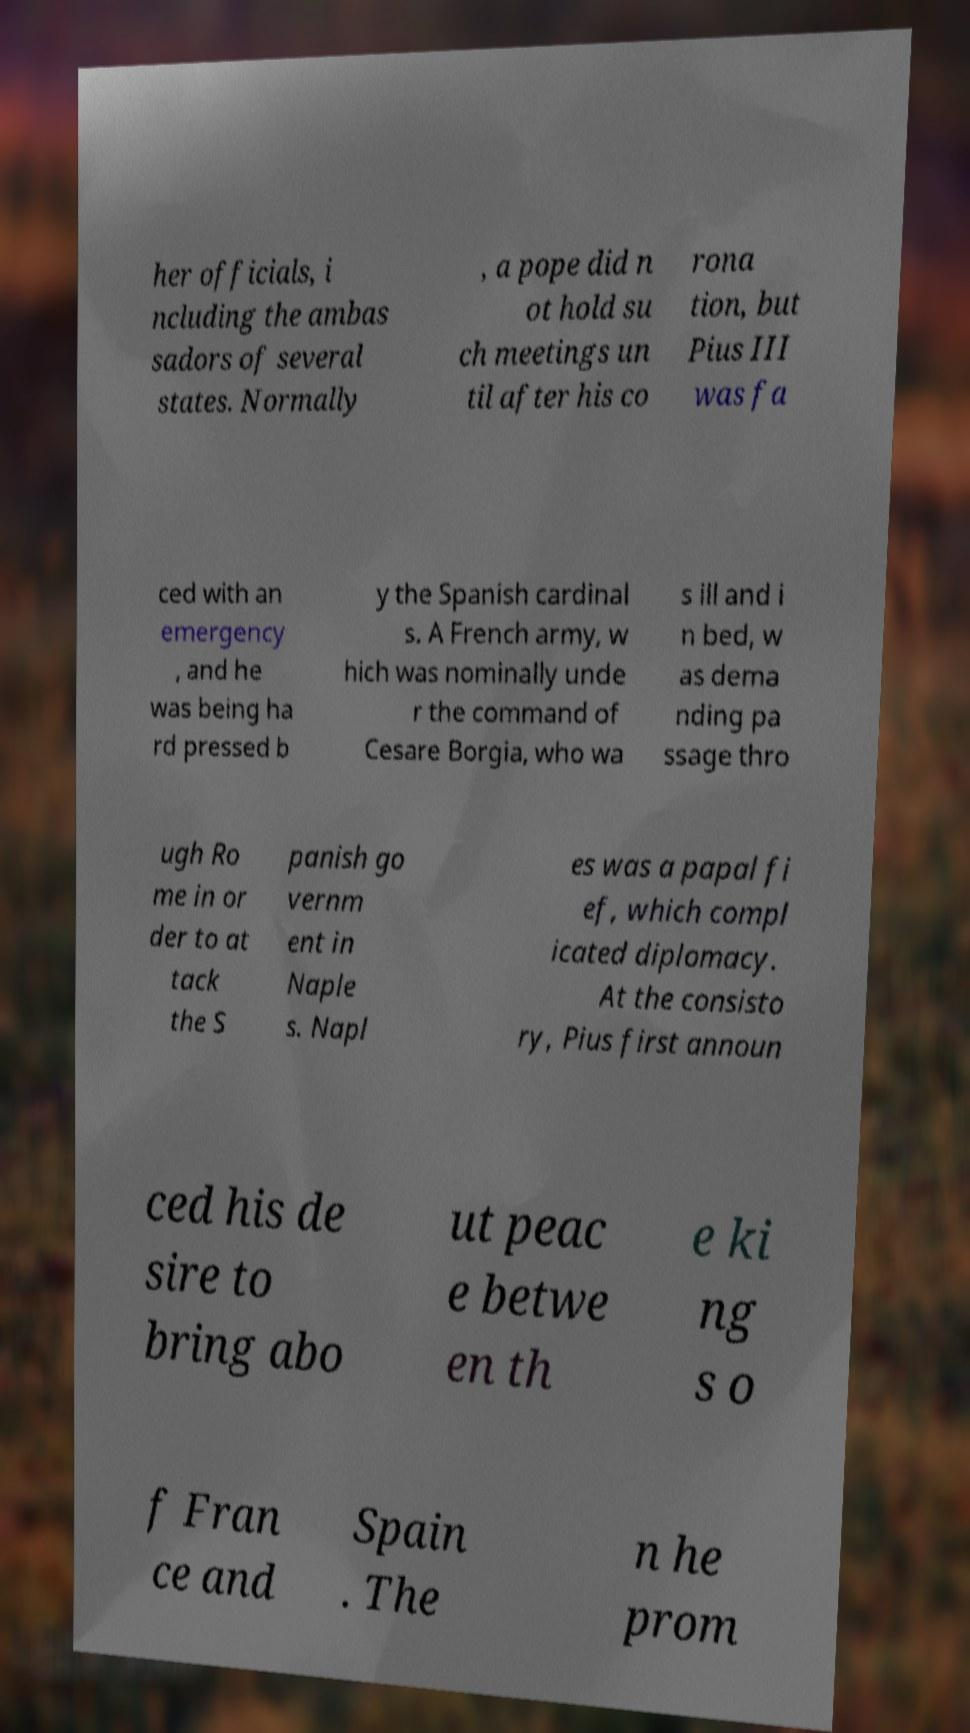There's text embedded in this image that I need extracted. Can you transcribe it verbatim? her officials, i ncluding the ambas sadors of several states. Normally , a pope did n ot hold su ch meetings un til after his co rona tion, but Pius III was fa ced with an emergency , and he was being ha rd pressed b y the Spanish cardinal s. A French army, w hich was nominally unde r the command of Cesare Borgia, who wa s ill and i n bed, w as dema nding pa ssage thro ugh Ro me in or der to at tack the S panish go vernm ent in Naple s. Napl es was a papal fi ef, which compl icated diplomacy. At the consisto ry, Pius first announ ced his de sire to bring abo ut peac e betwe en th e ki ng s o f Fran ce and Spain . The n he prom 